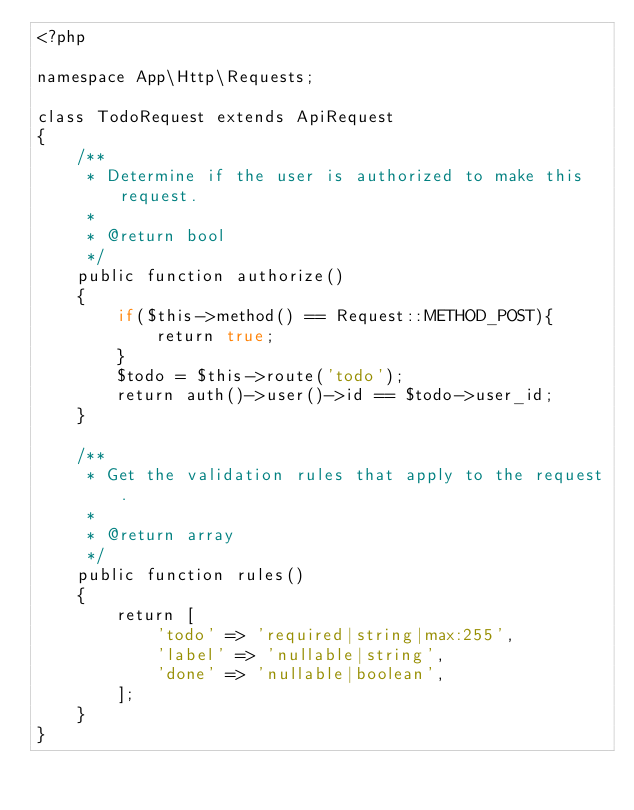<code> <loc_0><loc_0><loc_500><loc_500><_PHP_><?php

namespace App\Http\Requests;

class TodoRequest extends ApiRequest
{
    /**
     * Determine if the user is authorized to make this request.
     *
     * @return bool
     */
    public function authorize()
    {
        if($this->method() == Request::METHOD_POST){
            return true;
        }
        $todo = $this->route('todo');
        return auth()->user()->id == $todo->user_id;
    }

    /**
     * Get the validation rules that apply to the request.
     *
     * @return array
     */
    public function rules()
    {
        return [
            'todo' => 'required|string|max:255',
            'label' => 'nullable|string',
            'done' => 'nullable|boolean',
        ];
    }
}</code> 